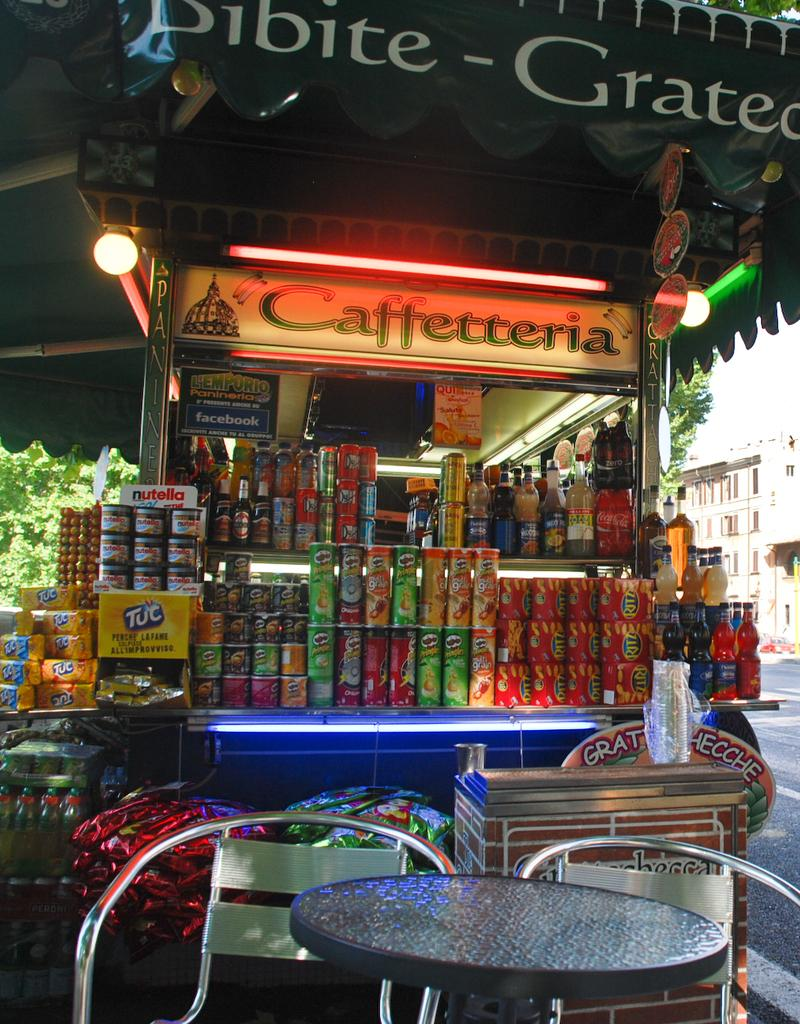<image>
Offer a succinct explanation of the picture presented. A stand saying caffetteria with a bunch of brands on it 